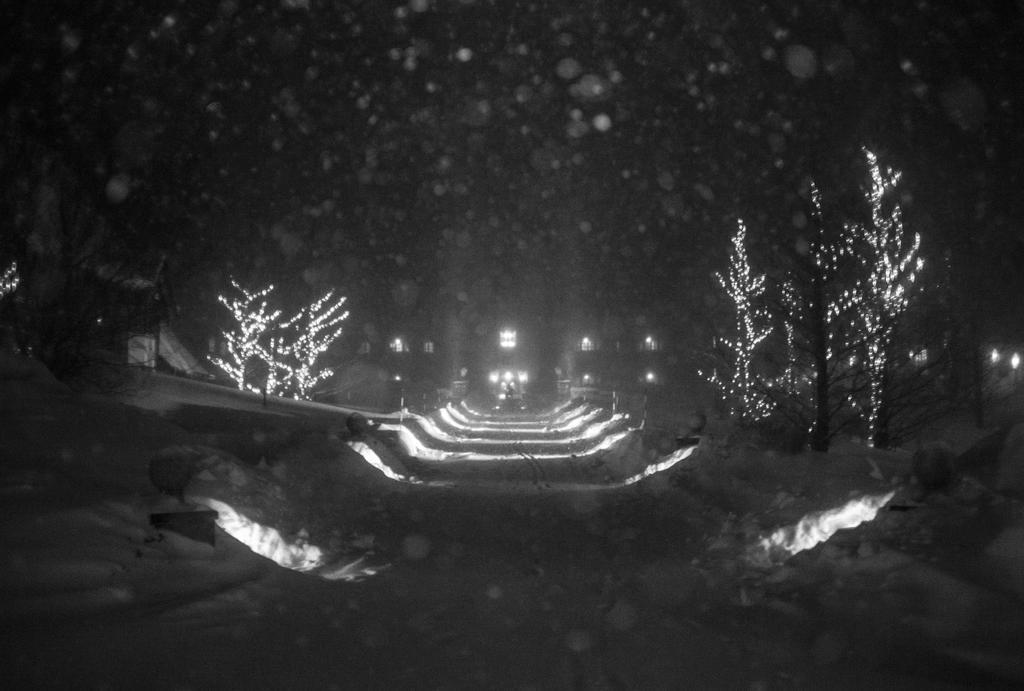Could you give a brief overview of what you see in this image? In this image, in the middle there are lights, trees, plants, buildings, windows, sky. 